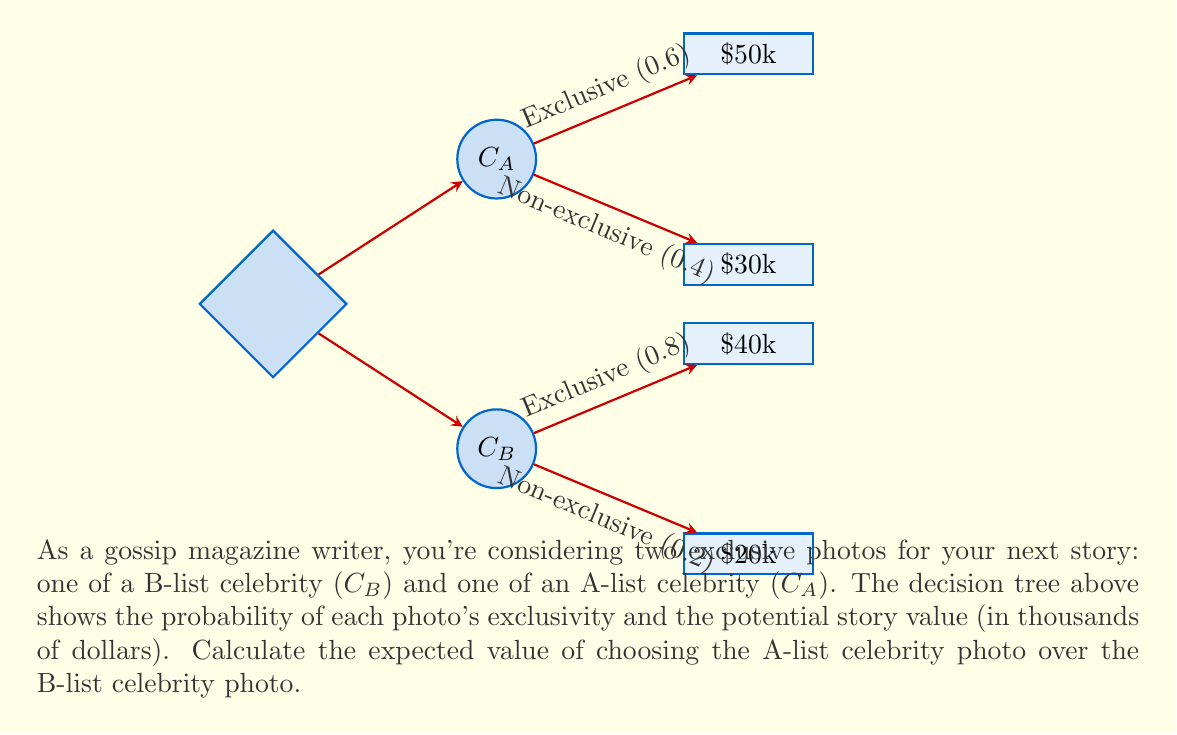Provide a solution to this math problem. Let's approach this step-by-step:

1) First, we need to calculate the expected value of choosing the A-list celebrity photo ($EV(C_A)$):

   $EV(C_A) = (0.6 \times 50) + (0.4 \times 30)$
   $= 30 + 12 = 42$ thousand dollars

2) Next, we calculate the expected value of choosing the B-list celebrity photo ($EV(C_B)$):

   $EV(C_B) = (0.8 \times 40) + (0.2 \times 20)$
   $= 32 + 4 = 36$ thousand dollars

3) To find the difference in expected value, we subtract $EV(C_B)$ from $EV(C_A)$:

   $EV(C_A) - EV(C_B) = 42 - 36 = 6$ thousand dollars

Therefore, choosing the A-list celebrity photo has an expected value that is $6,000 higher than choosing the B-list celebrity photo.
Answer: $6,000 